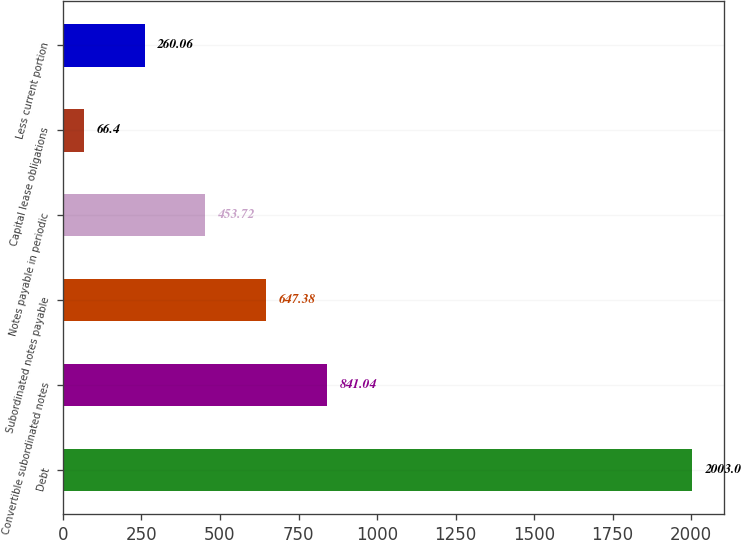<chart> <loc_0><loc_0><loc_500><loc_500><bar_chart><fcel>Debt<fcel>Convertible subordinated notes<fcel>Subordinated notes payable<fcel>Notes payable in periodic<fcel>Capital lease obligations<fcel>Less current portion<nl><fcel>2003<fcel>841.04<fcel>647.38<fcel>453.72<fcel>66.4<fcel>260.06<nl></chart> 